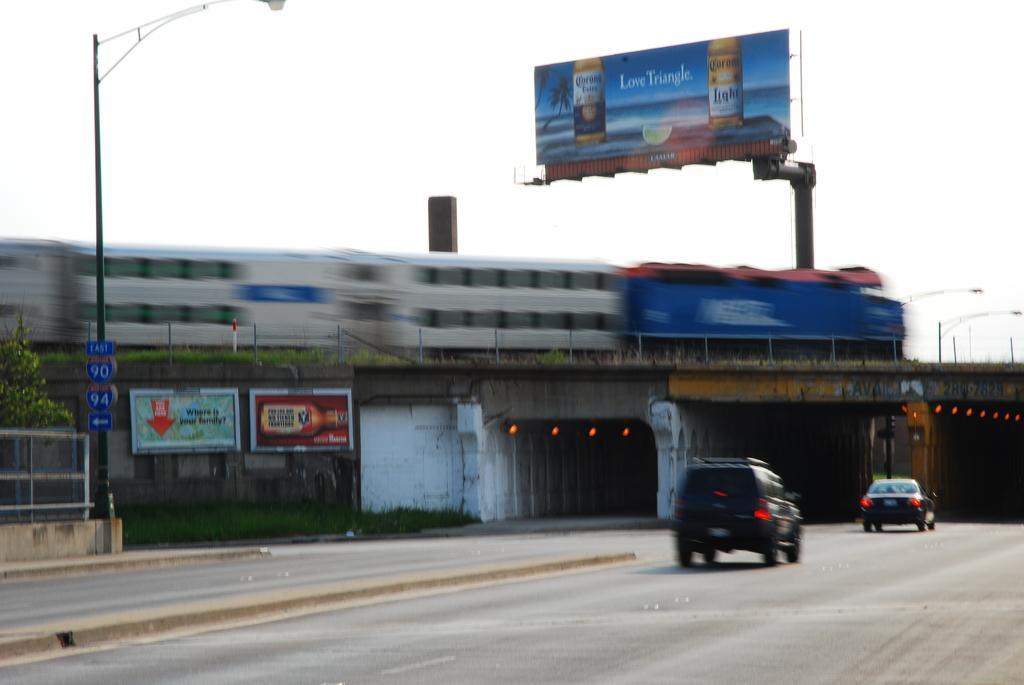Please provide a concise description of this image. In this image, we can see a train on the bridge. There are vehicles on the road. There is a street pole and plant on the left side of the image. There is a hoarding and sky at the top of the image. 